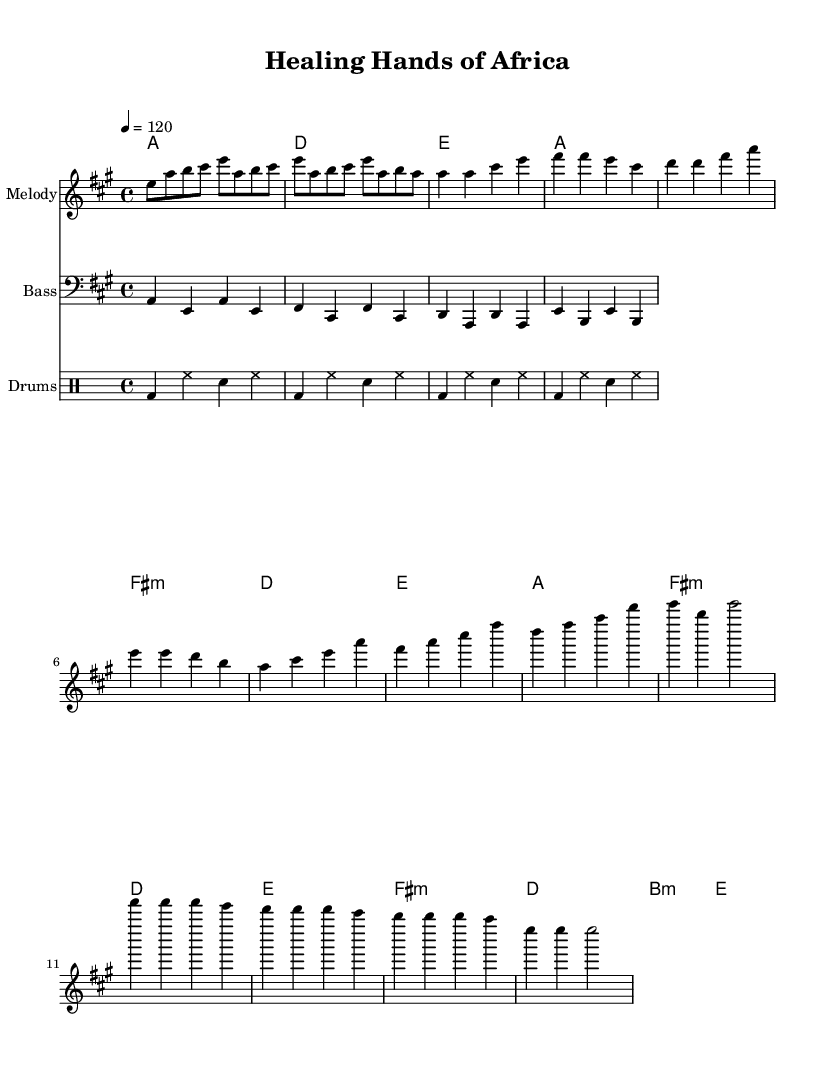What is the key signature of this music? The key signature is A major, which has three sharps (F#, C#, and G#). This can be identified by looking at the key signature clef at the beginning of the staff.
Answer: A major What is the time signature of this music? The time signature is 4/4, which is located at the beginning of the score, indicating that there are four beats in a measure and the quarter note gets one beat.
Answer: 4/4 What is the tempo marking for this piece? The tempo marking is 120 beats per minute, specified in the score which instructs how fast the piece should be played. Tempo markings are usually given at the beginning of the piece.
Answer: 120 How many measures are in the chorus section? The chorus section contains four measures, identified by looking at the note groups and counting them within the specified section of the music.
Answer: 4 What instrument plays the melody? The instrument that plays the melody is labeled as "Melody" on the staff, which is the top staff in the score. This indicates what instrument is intended to play that part.
Answer: Melody What type of drum pattern is provided in the score? The drum pattern consists of a basic rock beat, characterized by a kick drum (bd), hi-hat (hh), and snare (sn), played in a recurring pattern throughout the piece. This is a typical characteristic of disco music.
Answer: Basic drum pattern What harmonic structure is present in the verse? The harmonic structure in the verse includes four chords: A major, F# minor, D major, and E major, played in sequence as indicated in the chord mode area of the score. This forms the foundation of the verse's progression.
Answer: A, F# minor, D, E 